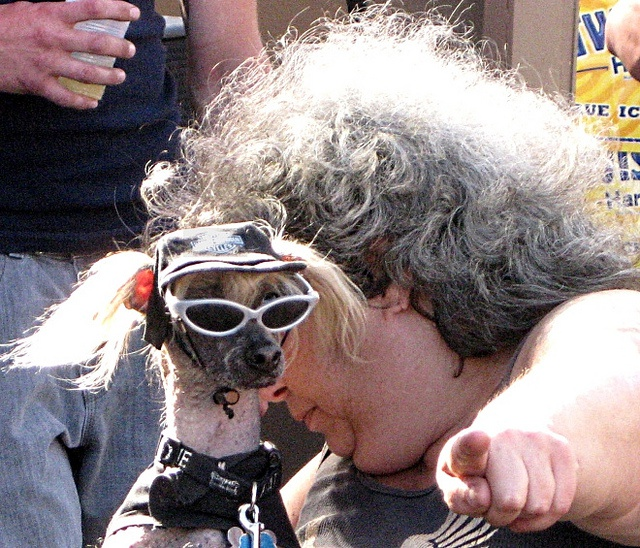Describe the objects in this image and their specific colors. I can see people in black, white, gray, and brown tones, people in black and gray tones, dog in black, white, gray, and darkgray tones, and cup in black, darkgray, gray, and tan tones in this image. 